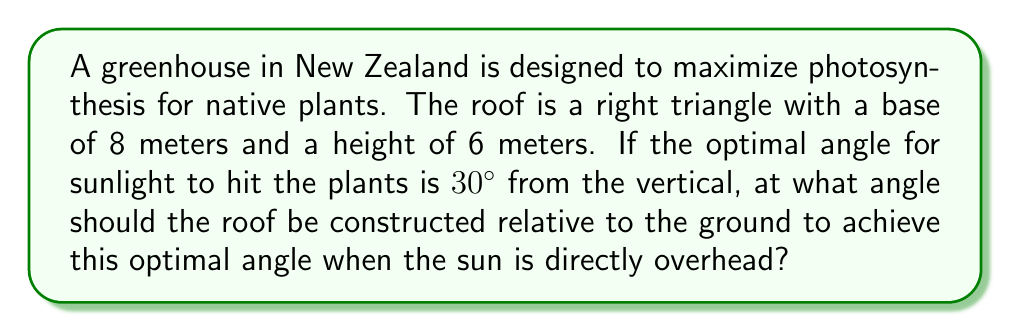Provide a solution to this math problem. Let's approach this step-by-step:

1) First, let's visualize the problem:

[asy]
import geometry;

size(200);

pair A = (0,0), B = (8,0), C = (0,6);
draw(A--B--C--A);

pair D = (0,6.5);
draw(D--B,dashed);

draw(rightangle(A,B,C,0.5));

label("8m",B,(0,-1));
label("6m",C,(0,1));
label("$\theta$",(1,0.5));
label("30°",(0.5,6));

dot("A",A,SW);
dot("B",B,SE);
dot("C",C,NW);
dot("D",D,N);
[/asy]

2) We need to find the angle $\theta$ between the roof (CB) and the ground (AB).

3) The optimal angle for sunlight is 30° from the vertical. This means the roof should be at a 60° angle from the horizontal (90° - 30° = 60°).

4) We can find $\theta$ by subtracting this 60° from 90°:

   $\theta = 90° - 60° = 30°$

5) Let's verify this using the dimensions of the roof:

   $\tan \theta = \frac{\text{opposite}}{\text{adjacent}} = \frac{6}{8} = 0.75$

6) We can confirm that:

   $\tan 30° = \frac{1}{\sqrt{3}} \approx 0.577$

7) The arctangent of 0.75 is indeed approximately 30°:

   $\theta = \arctan(0.75) \approx 30°$

Therefore, the roof should be constructed at a 30° angle relative to the ground.
Answer: 30° 